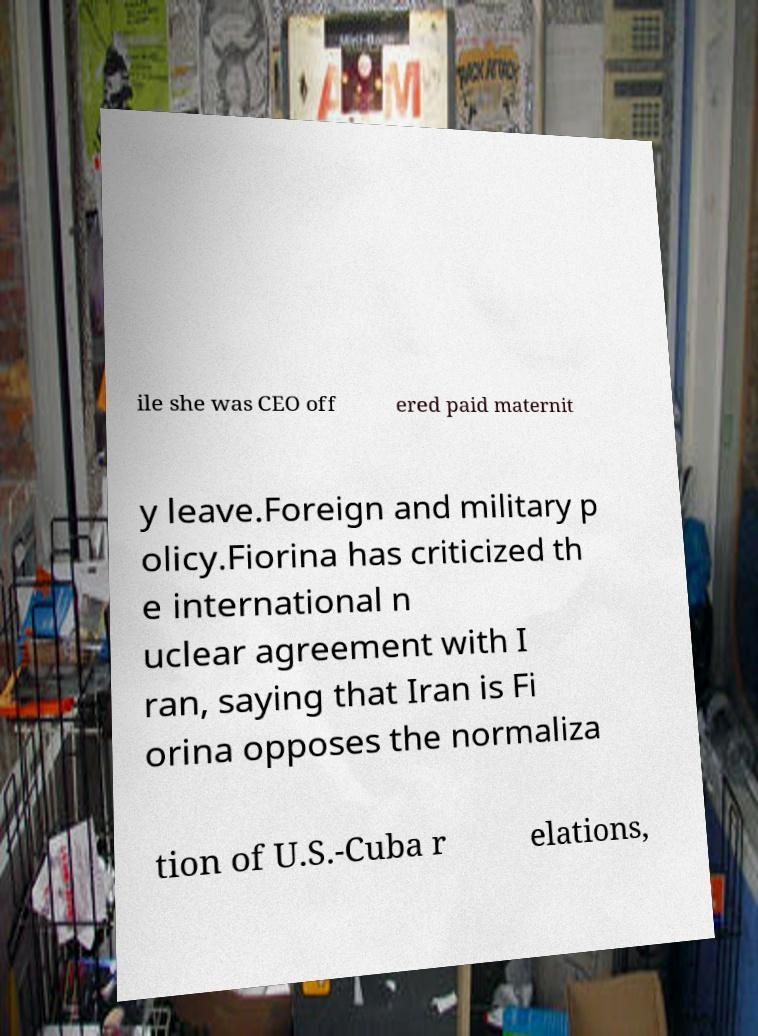Please identify and transcribe the text found in this image. ile she was CEO off ered paid maternit y leave.Foreign and military p olicy.Fiorina has criticized th e international n uclear agreement with I ran, saying that Iran is Fi orina opposes the normaliza tion of U.S.-Cuba r elations, 